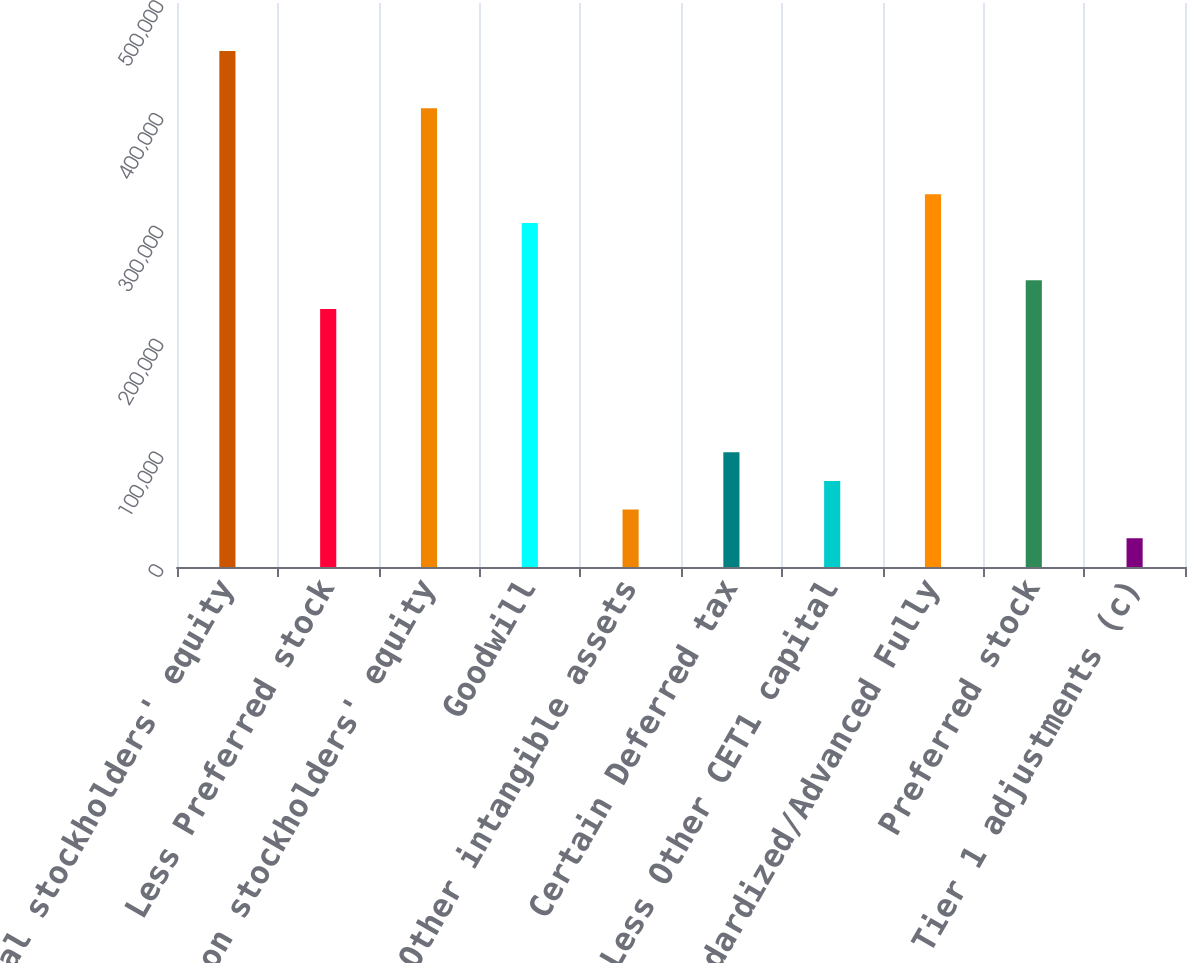Convert chart to OTSL. <chart><loc_0><loc_0><loc_500><loc_500><bar_chart><fcel>Total stockholders' equity<fcel>Less Preferred stock<fcel>Common stockholders' equity<fcel>Goodwill<fcel>Other intangible assets<fcel>Certain Deferred tax<fcel>Less Other CET1 capital<fcel>Standardized/Advanced Fully<fcel>Preferred stock<fcel>Other Tier 1 adjustments (c)<nl><fcel>457467<fcel>228780<fcel>406648<fcel>305009<fcel>50913.2<fcel>101732<fcel>76322.8<fcel>330419<fcel>254190<fcel>25503.6<nl></chart> 